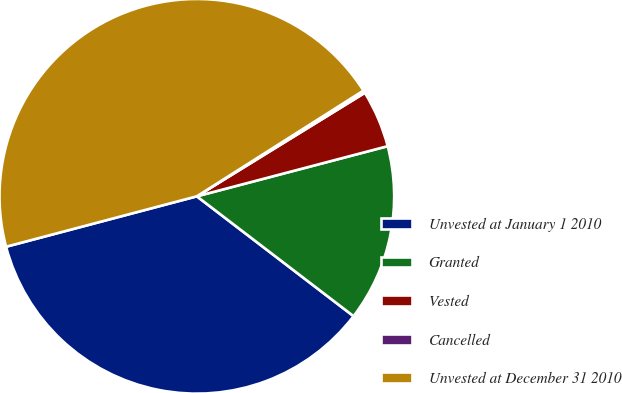Convert chart to OTSL. <chart><loc_0><loc_0><loc_500><loc_500><pie_chart><fcel>Unvested at January 1 2010<fcel>Granted<fcel>Vested<fcel>Cancelled<fcel>Unvested at December 31 2010<nl><fcel>35.5%<fcel>14.48%<fcel>4.7%<fcel>0.21%<fcel>45.12%<nl></chart> 